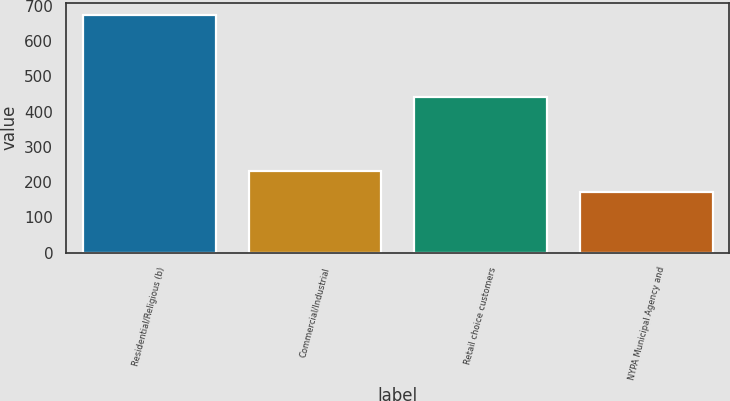<chart> <loc_0><loc_0><loc_500><loc_500><bar_chart><fcel>Residential/Religious (b)<fcel>Commercial/Industrial<fcel>Retail choice customers<fcel>NYPA Municipal Agency and<nl><fcel>675<fcel>232<fcel>441<fcel>172<nl></chart> 